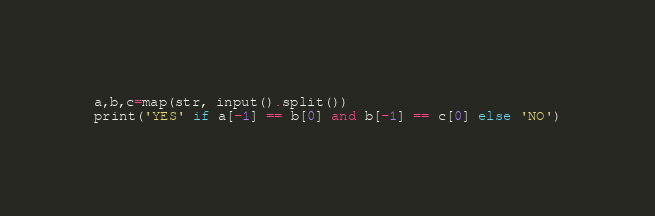Convert code to text. <code><loc_0><loc_0><loc_500><loc_500><_Python_>a,b,c=map(str, input().split())
print('YES' if a[-1] == b[0] and b[-1] == c[0] else 'NO')</code> 